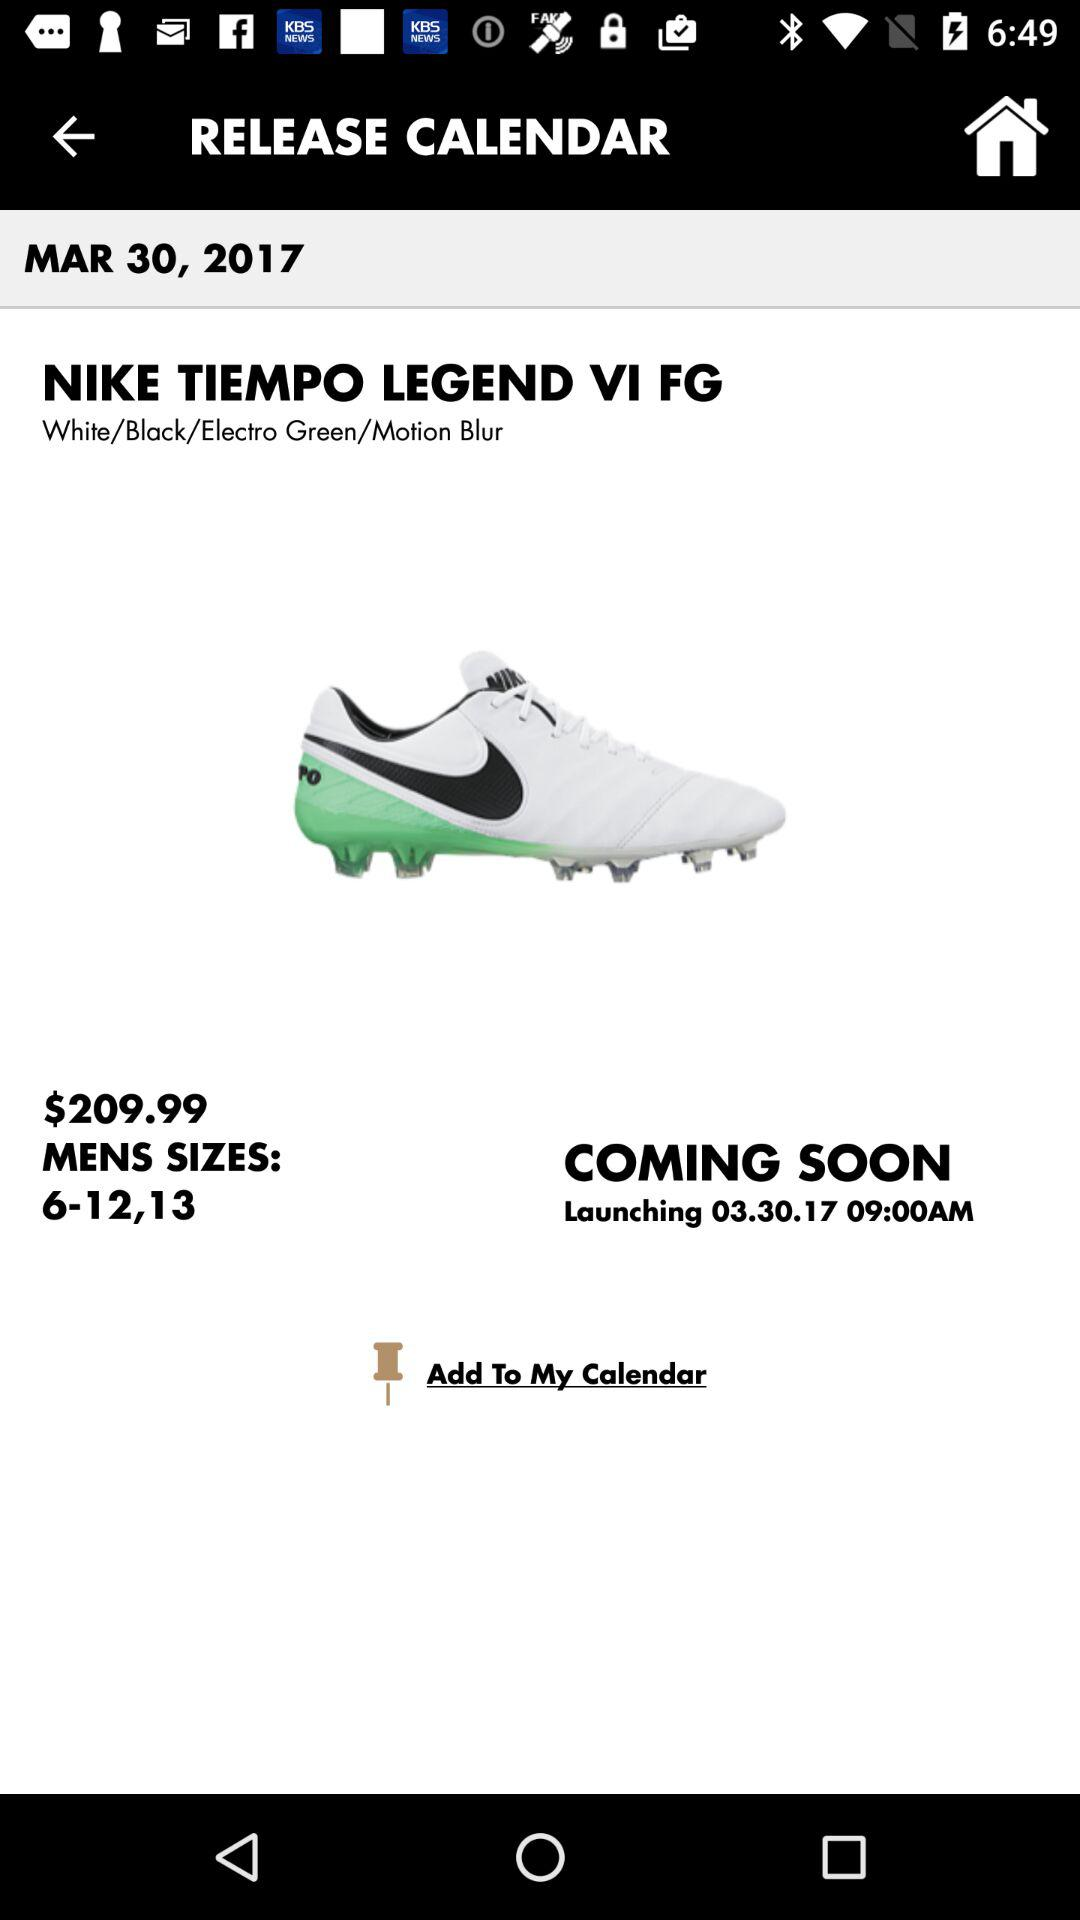What is the launch date and time? The launch date is March 30, 2017, and the time is 9:00 AM. 